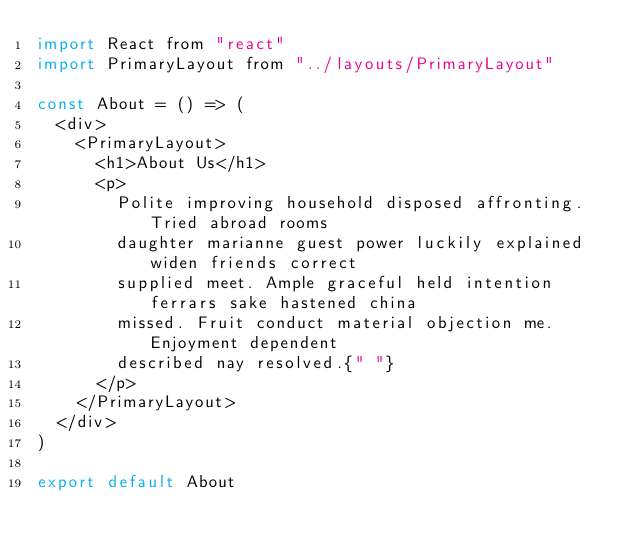<code> <loc_0><loc_0><loc_500><loc_500><_JavaScript_>import React from "react"
import PrimaryLayout from "../layouts/PrimaryLayout"

const About = () => (
  <div>
    <PrimaryLayout>
      <h1>About Us</h1>
      <p>
        Polite improving household disposed affronting. Tried abroad rooms
        daughter marianne guest power luckily explained widen friends correct
        supplied meet. Ample graceful held intention ferrars sake hastened china
        missed. Fruit conduct material objection me. Enjoyment dependent
        described nay resolved.{" "}
      </p>
    </PrimaryLayout>
  </div>
)

export default About
</code> 